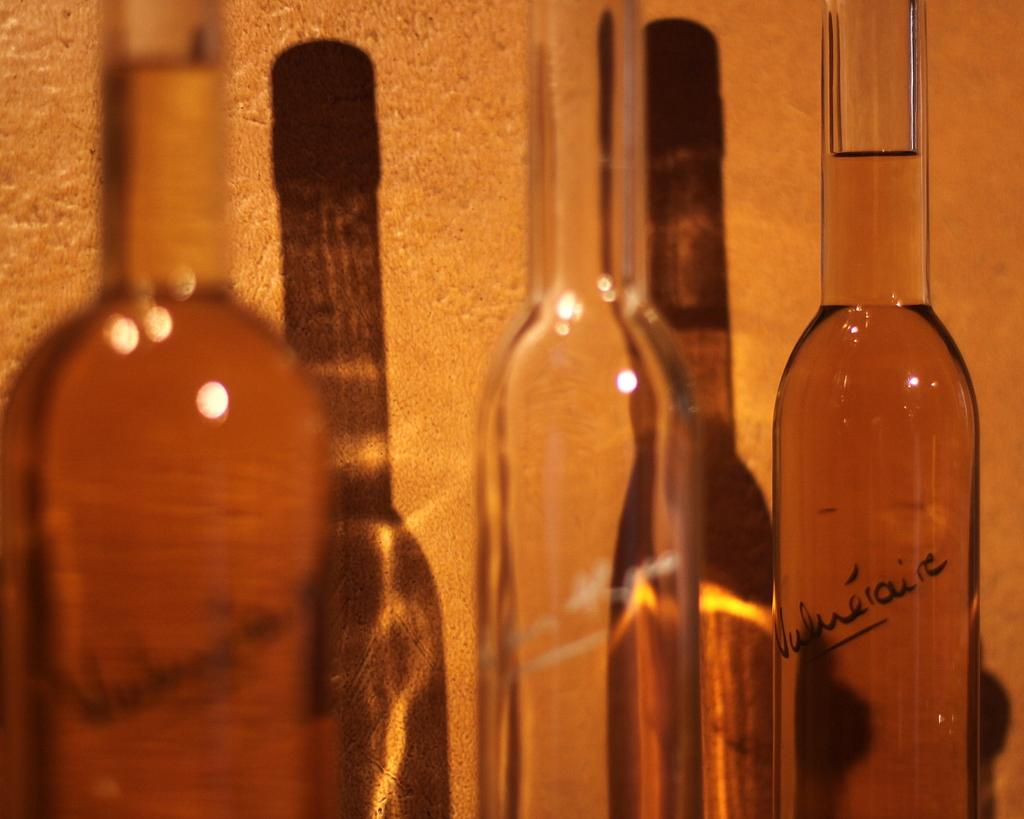What type of containers are visible in the image? There are glass bottles in the image. Where are the glass bottles located in the image? The glass bottles are arranged at a side of the image. How many snails can be seen crawling on the glass bottles in the image? There are no snails visible on the glass bottles in the image. What type of pin is used to secure the labels on the glass bottles in the image? There is no mention of pins or labels on the glass bottles in the image. 